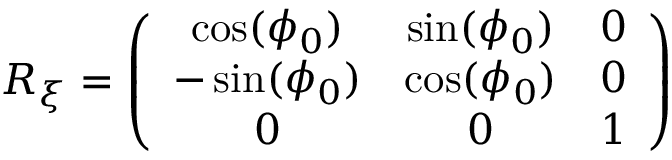Convert formula to latex. <formula><loc_0><loc_0><loc_500><loc_500>\begin{array} { r } { R _ { \xi } = \left ( \begin{array} { c c c } { \cos ( \phi _ { 0 } ) } & { \sin ( \phi _ { 0 } ) } & { 0 } \\ { - \sin ( \phi _ { 0 } ) } & { \cos ( \phi _ { 0 } ) } & { 0 } \\ { 0 } & { 0 } & { 1 } \end{array} \right ) } \end{array}</formula> 